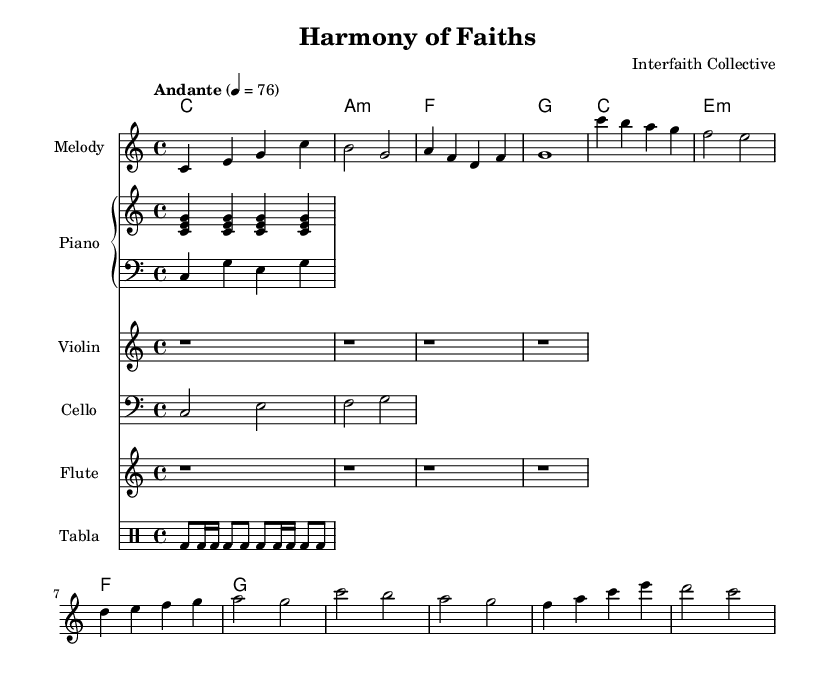What is the key signature of this music? The key signature is C major, indicated by the absence of sharps or flats.
Answer: C major What is the time signature of this piece? The time signature is found at the beginning of the piece, indicating four beats per measure.
Answer: 4/4 What is the tempo marking of this music? The tempo marking indicates "Andante," which suggests a moderate pace. The number 76 gives the beats per minute for reference.
Answer: Andante How many measures are in the melody section? By counting the measures presented in the melody part, there are eight measures in total.
Answer: 8 Identify the names of the instruments used in this score. The score includes melody, piano, violin, cello, flute, and tabla, which are all indicated by their staff headings.
Answer: Melody, Piano, Violin, Cello, Flute, Tabla What is the main theme conveyed in the lyrics of the chorus? The theme of the chorus focuses on unity and the journey towards understanding among different faiths, emphasized through the phrasing "Unity in diversity."
Answer: Unity in diversity What chords are used in the harmonies section? The harmonies section indicates a progression of C major, A minor, F major, and G major, denoting the basic chords used throughout.
Answer: C, A minor, F, G 